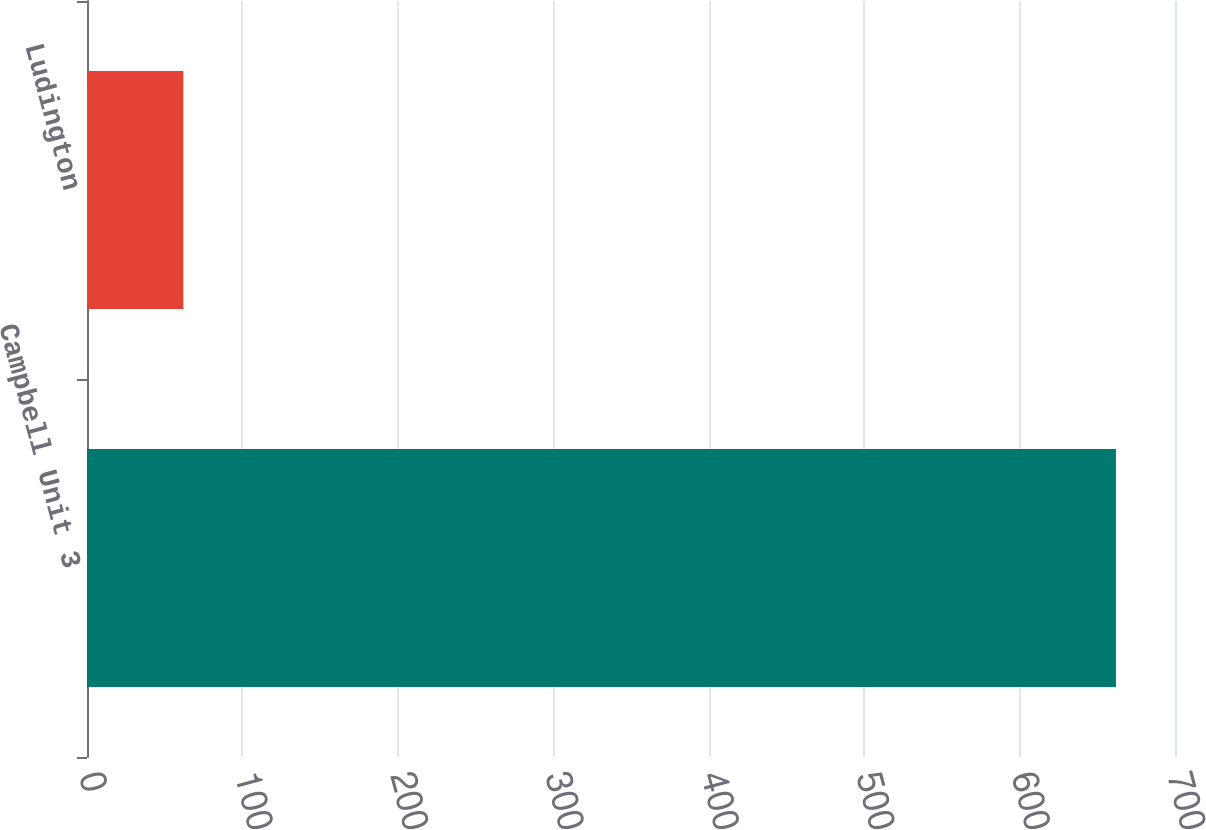Convert chart to OTSL. <chart><loc_0><loc_0><loc_500><loc_500><bar_chart><fcel>Campbell Unit 3<fcel>Ludington<nl><fcel>662<fcel>62<nl></chart> 